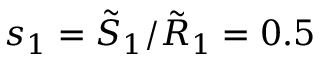Convert formula to latex. <formula><loc_0><loc_0><loc_500><loc_500>s _ { 1 } = \tilde { S } _ { 1 } / \tilde { R } _ { 1 } = 0 . 5</formula> 